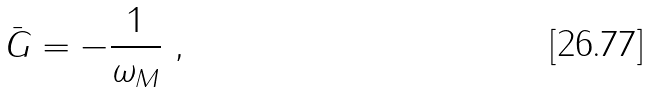Convert formula to latex. <formula><loc_0><loc_0><loc_500><loc_500>\bar { G } = - \frac { 1 } { \omega _ { M } } \ ,</formula> 